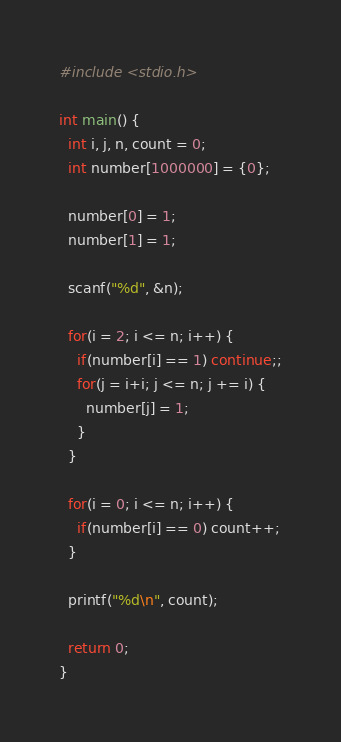<code> <loc_0><loc_0><loc_500><loc_500><_C_>#include <stdio.h>

int main() {
  int i, j, n, count = 0;
  int number[1000000] = {0};

  number[0] = 1;
  number[1] = 1;

  scanf("%d", &n);

  for(i = 2; i <= n; i++) {
    if(number[i] == 1) continue;;
    for(j = i+i; j <= n; j += i) {
      number[j] = 1;
    }
  }

  for(i = 0; i <= n; i++) {
    if(number[i] == 0) count++;
  }

  printf("%d\n", count);

  return 0;
}</code> 